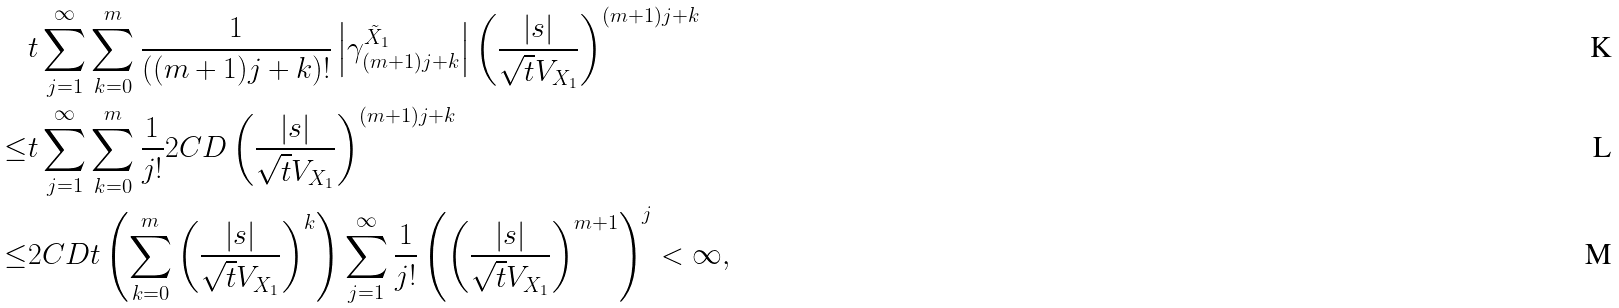Convert formula to latex. <formula><loc_0><loc_0><loc_500><loc_500>& t \sum _ { j = 1 } ^ { \infty } \sum _ { k = 0 } ^ { m } \frac { 1 } { ( ( m + 1 ) j + k ) ! } \left | \gamma _ { ( m + 1 ) j + k } ^ { \tilde { X } _ { 1 } } \right | \left ( \frac { | s | } { \sqrt { t } V _ { X _ { 1 } } } \right ) ^ { ( m + 1 ) j + k } \\ \leq & t \sum _ { j = 1 } ^ { \infty } \sum _ { k = 0 } ^ { m } \frac { 1 } { j ! } 2 C D \left ( \frac { | s | } { \sqrt { t } V _ { X _ { 1 } } } \right ) ^ { ( m + 1 ) j + k } \\ \leq & 2 C D t \left ( \sum _ { k = 0 } ^ { m } \left ( \frac { | s | } { \sqrt { t } V _ { X _ { 1 } } } \right ) ^ { k } \right ) \sum _ { j = 1 } ^ { \infty } \frac { 1 } { j ! } \left ( \left ( \frac { | s | } { \sqrt { t } V _ { X _ { 1 } } } \right ) ^ { m + 1 } \right ) ^ { j } < \infty ,</formula> 